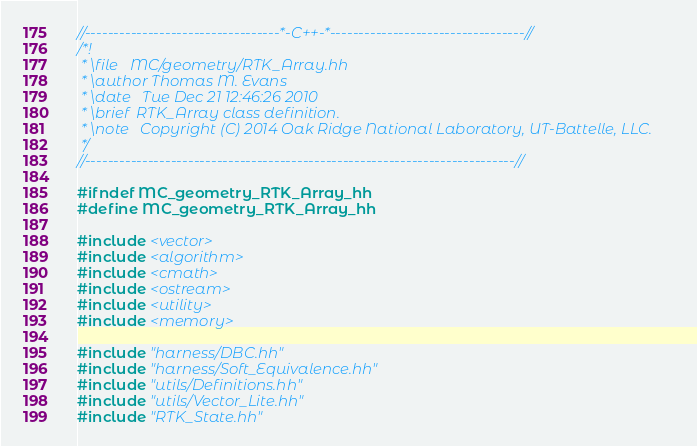Convert code to text. <code><loc_0><loc_0><loc_500><loc_500><_C++_>//----------------------------------*-C++-*----------------------------------//
/*!
 * \file   MC/geometry/RTK_Array.hh
 * \author Thomas M. Evans
 * \date   Tue Dec 21 12:46:26 2010
 * \brief  RTK_Array class definition.
 * \note   Copyright (C) 2014 Oak Ridge National Laboratory, UT-Battelle, LLC.
 */
//---------------------------------------------------------------------------//

#ifndef MC_geometry_RTK_Array_hh
#define MC_geometry_RTK_Array_hh

#include <vector>
#include <algorithm>
#include <cmath>
#include <ostream>
#include <utility>
#include <memory>

#include "harness/DBC.hh"
#include "harness/Soft_Equivalence.hh"
#include "utils/Definitions.hh"
#include "utils/Vector_Lite.hh"
#include "RTK_State.hh"
</code> 